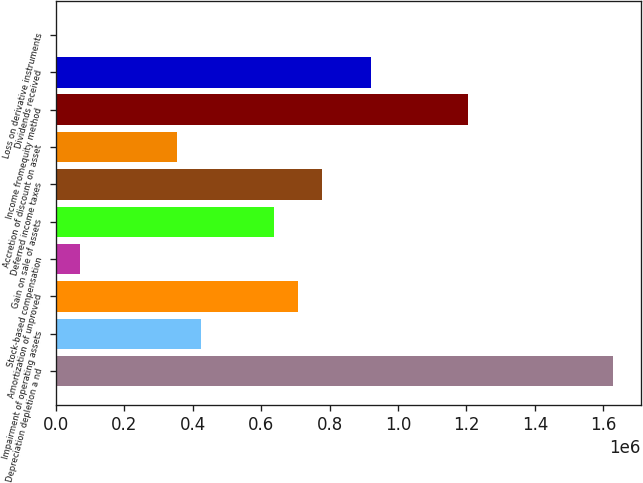<chart> <loc_0><loc_0><loc_500><loc_500><bar_chart><fcel>Depreciation depletion a nd<fcel>Impairment of operating assets<fcel>Amortization of unproved<fcel>Stock-based compensation<fcel>Gain on sale of assets<fcel>Deferred income taxes<fcel>Accretion of discount on asset<fcel>Income fromequity method<fcel>Dividends received<fcel>Loss on derivative instruments<nl><fcel>1.62847e+06<fcel>425020<fcel>708186<fcel>71063.4<fcel>637395<fcel>778977<fcel>354229<fcel>1.20373e+06<fcel>920560<fcel>272<nl></chart> 